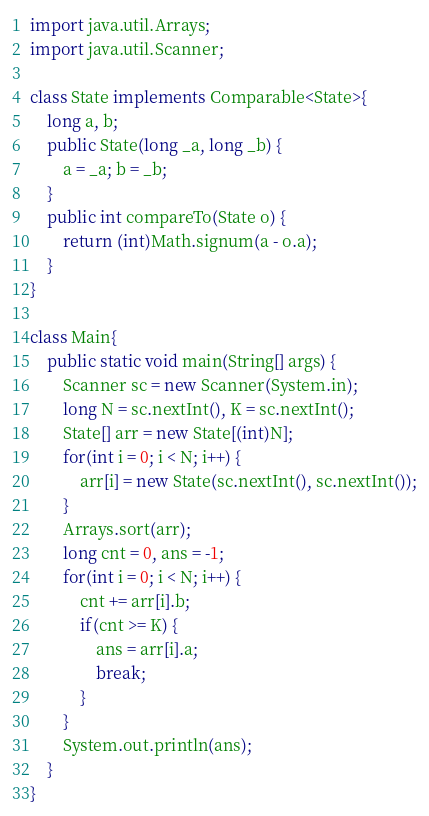Convert code to text. <code><loc_0><loc_0><loc_500><loc_500><_Java_>import java.util.Arrays;
import java.util.Scanner;

class State implements Comparable<State>{
	long a, b;
	public State(long _a, long _b) {
		a = _a; b = _b;
	}
	public int compareTo(State o) {
		return (int)Math.signum(a - o.a);
	}
}

class Main{
	public static void main(String[] args) {
		Scanner sc = new Scanner(System.in);
		long N = sc.nextInt(), K = sc.nextInt();
		State[] arr = new State[(int)N];
		for(int i = 0; i < N; i++) {
			arr[i] = new State(sc.nextInt(), sc.nextInt());
		}
		Arrays.sort(arr);
		long cnt = 0, ans = -1;
		for(int i = 0; i < N; i++) {
			cnt += arr[i].b;
			if(cnt >= K) {
				ans = arr[i].a;
				break;
			}
		}
		System.out.println(ans);
	}
}</code> 